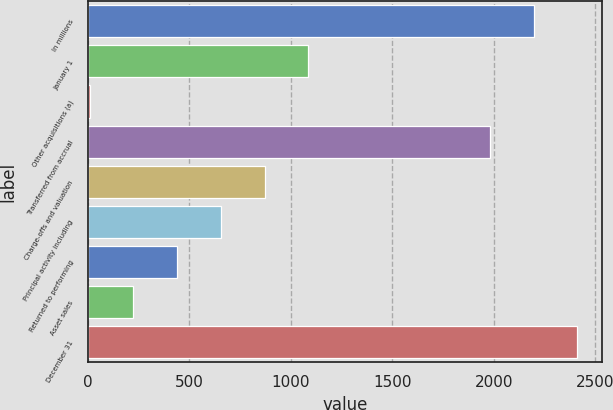<chart> <loc_0><loc_0><loc_500><loc_500><bar_chart><fcel>In millions<fcel>January 1<fcel>Other acquisitions (a)<fcel>Transferred from accrual<fcel>Charge-offs and valuation<fcel>Principal activity including<fcel>Returned to performing<fcel>Asset sales<fcel>December 31<nl><fcel>2196.6<fcel>1087<fcel>9<fcel>1981<fcel>871.4<fcel>655.8<fcel>440.2<fcel>224.6<fcel>2412.2<nl></chart> 